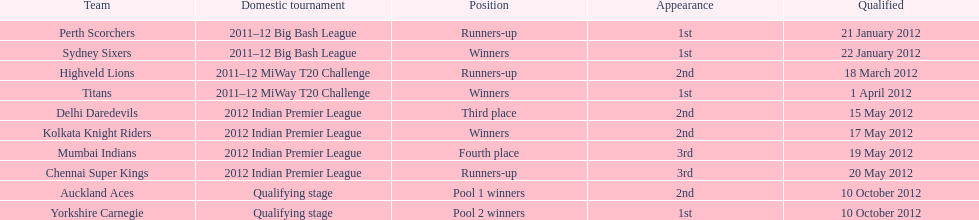Which game came in first in the 2012 indian premier league? Kolkata Knight Riders. 